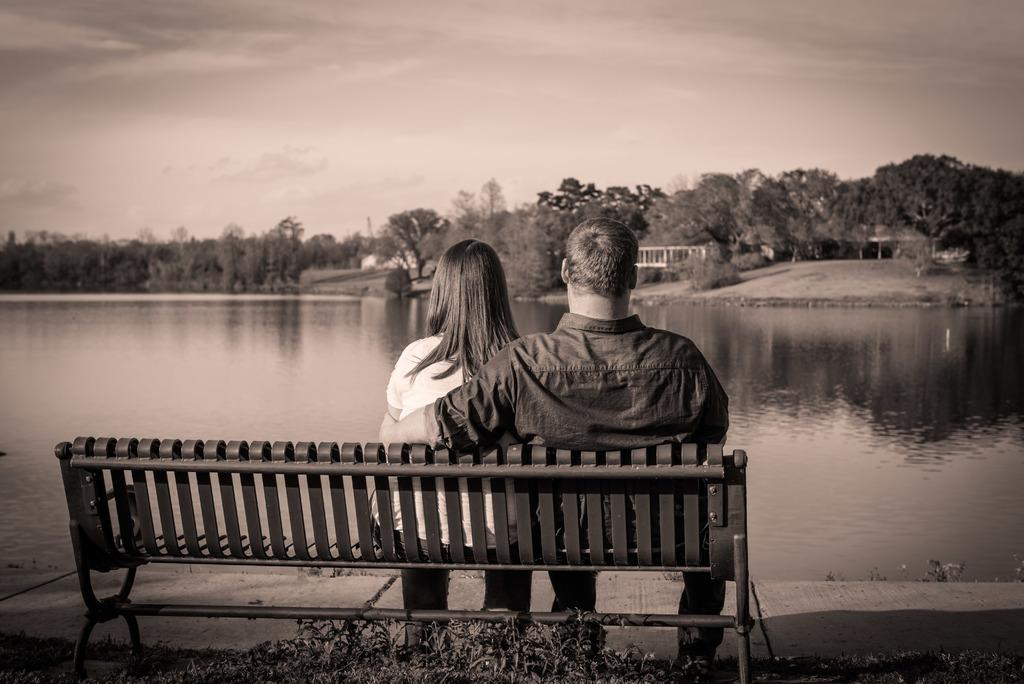What type of seating is present in the image? There is a bench in the image. How many people are sitting on the bench? Two people are sitting on the bench. What can be seen in the background of the image? There is water, trees, and the sky visible in the image. What sound can be heard coming from the ducks in the image? There are no ducks present in the image, so no sound can be heard from them. 